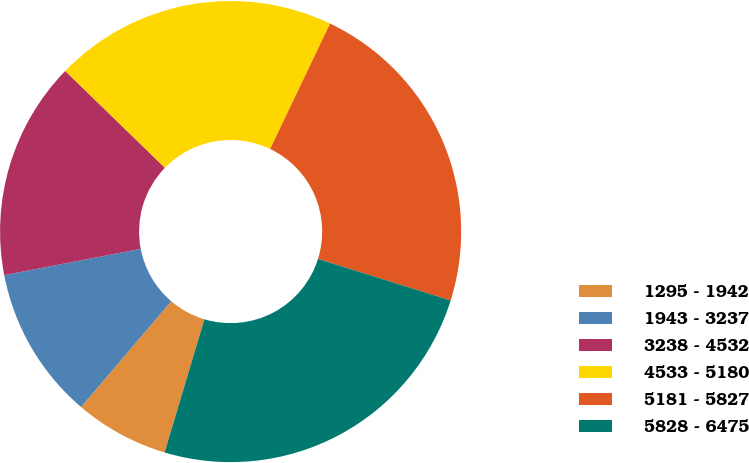Convert chart to OTSL. <chart><loc_0><loc_0><loc_500><loc_500><pie_chart><fcel>1295 - 1942<fcel>1943 - 3237<fcel>3238 - 4532<fcel>4533 - 5180<fcel>5181 - 5827<fcel>5828 - 6475<nl><fcel>6.61%<fcel>10.74%<fcel>15.29%<fcel>19.83%<fcel>22.73%<fcel>24.79%<nl></chart> 